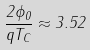<formula> <loc_0><loc_0><loc_500><loc_500>\frac { 2 \phi _ { 0 } } { q T _ { C } } \approx 3 . 5 2</formula> 